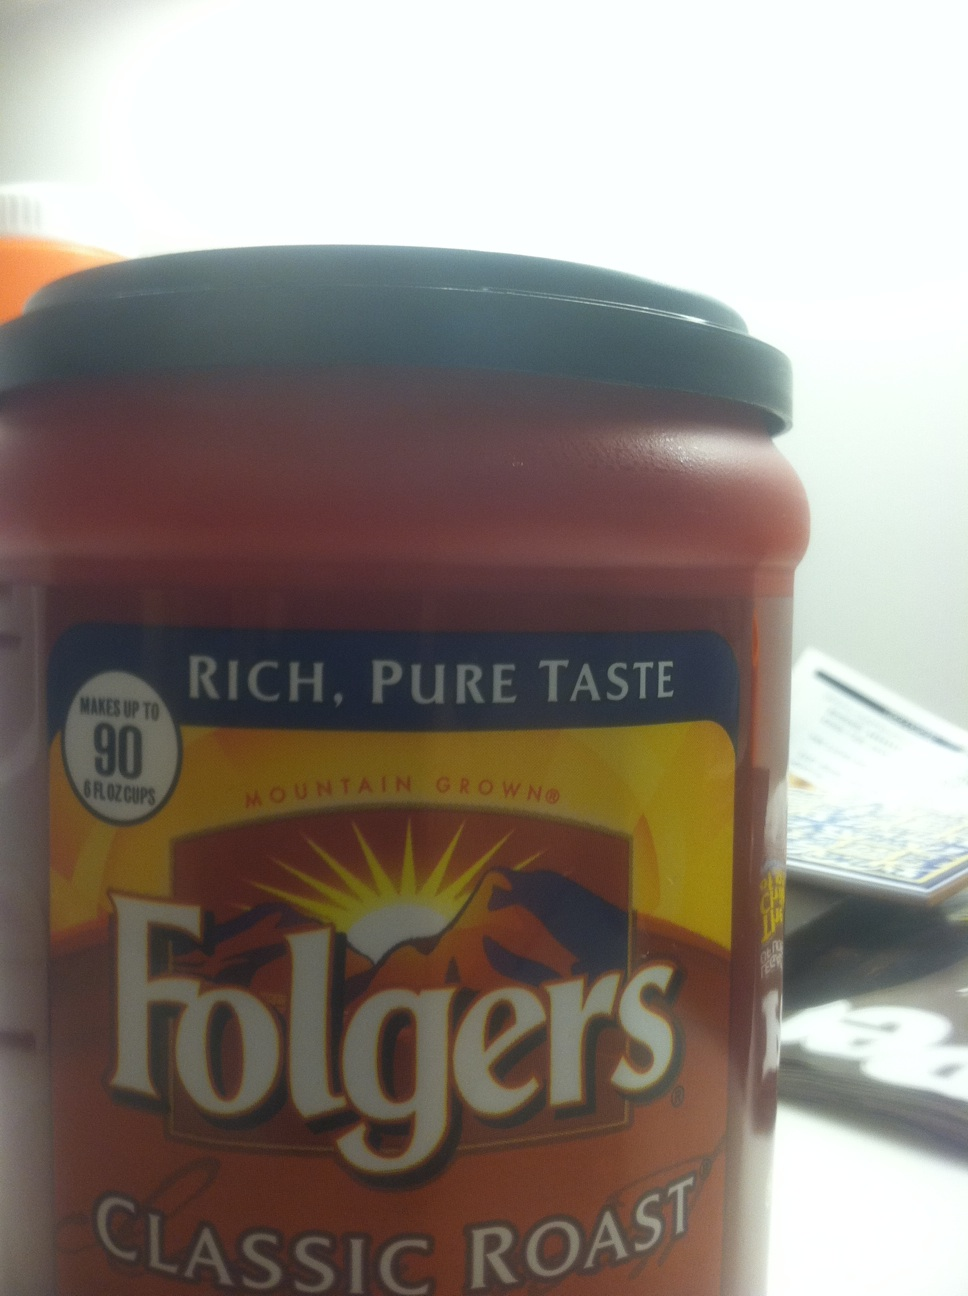What kind of coffee is this? from Vizwiz folgers classic roast 